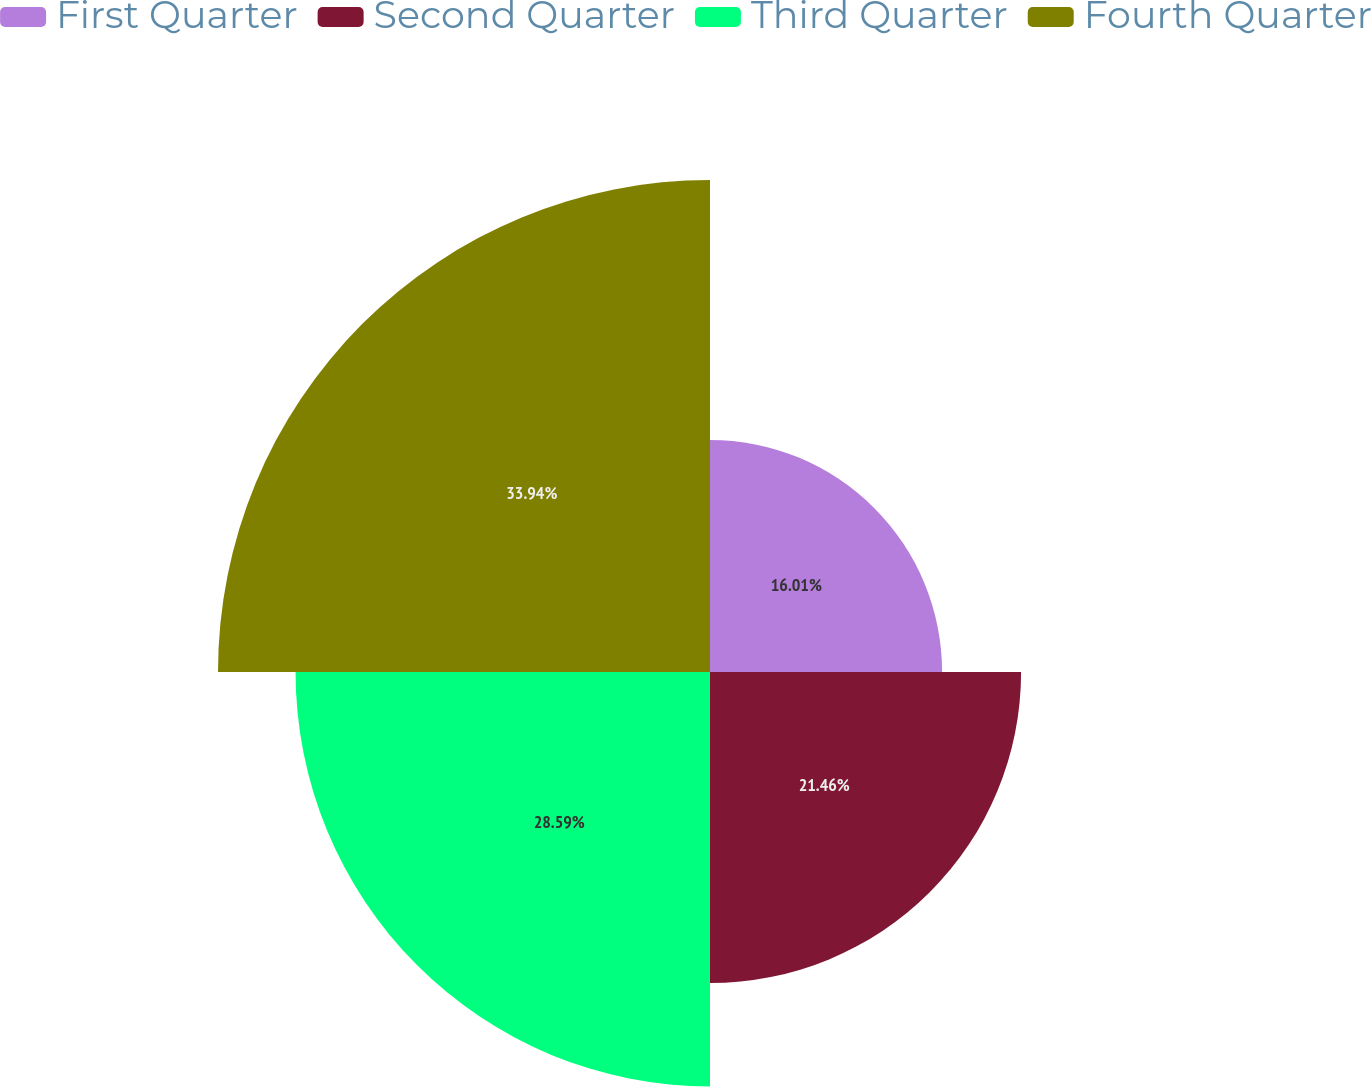<chart> <loc_0><loc_0><loc_500><loc_500><pie_chart><fcel>First Quarter<fcel>Second Quarter<fcel>Third Quarter<fcel>Fourth Quarter<nl><fcel>16.01%<fcel>21.46%<fcel>28.59%<fcel>33.94%<nl></chart> 